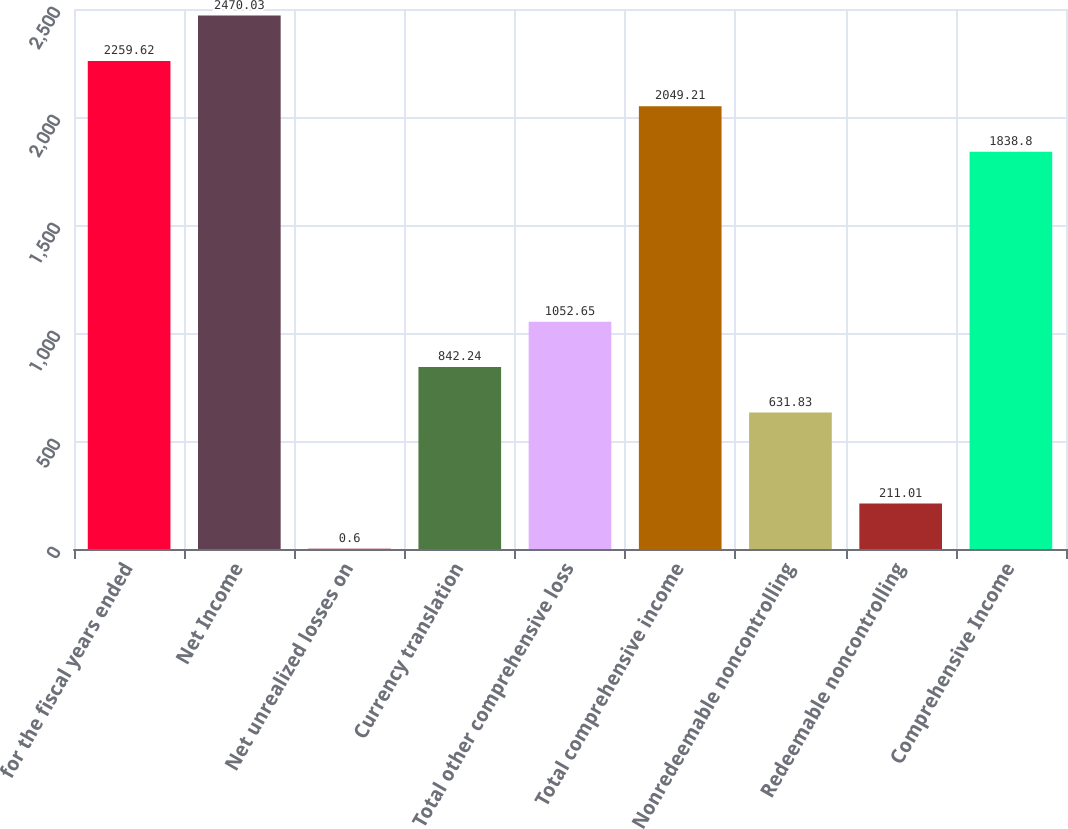<chart> <loc_0><loc_0><loc_500><loc_500><bar_chart><fcel>for the fiscal years ended<fcel>Net Income<fcel>Net unrealized losses on<fcel>Currency translation<fcel>Total other comprehensive loss<fcel>Total comprehensive income<fcel>Nonredeemable noncontrolling<fcel>Redeemable noncontrolling<fcel>Comprehensive Income<nl><fcel>2259.62<fcel>2470.03<fcel>0.6<fcel>842.24<fcel>1052.65<fcel>2049.21<fcel>631.83<fcel>211.01<fcel>1838.8<nl></chart> 